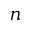Convert formula to latex. <formula><loc_0><loc_0><loc_500><loc_500>n</formula> 